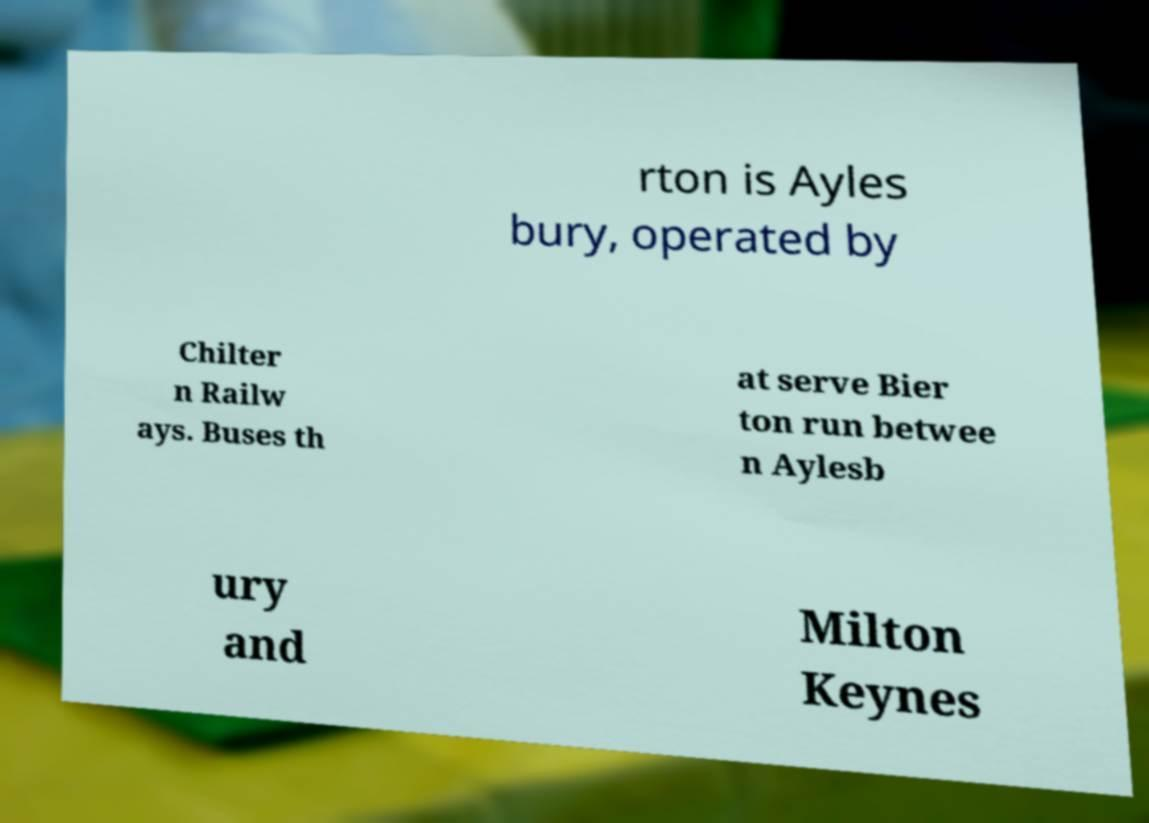Can you accurately transcribe the text from the provided image for me? rton is Ayles bury, operated by Chilter n Railw ays. Buses th at serve Bier ton run betwee n Aylesb ury and Milton Keynes 